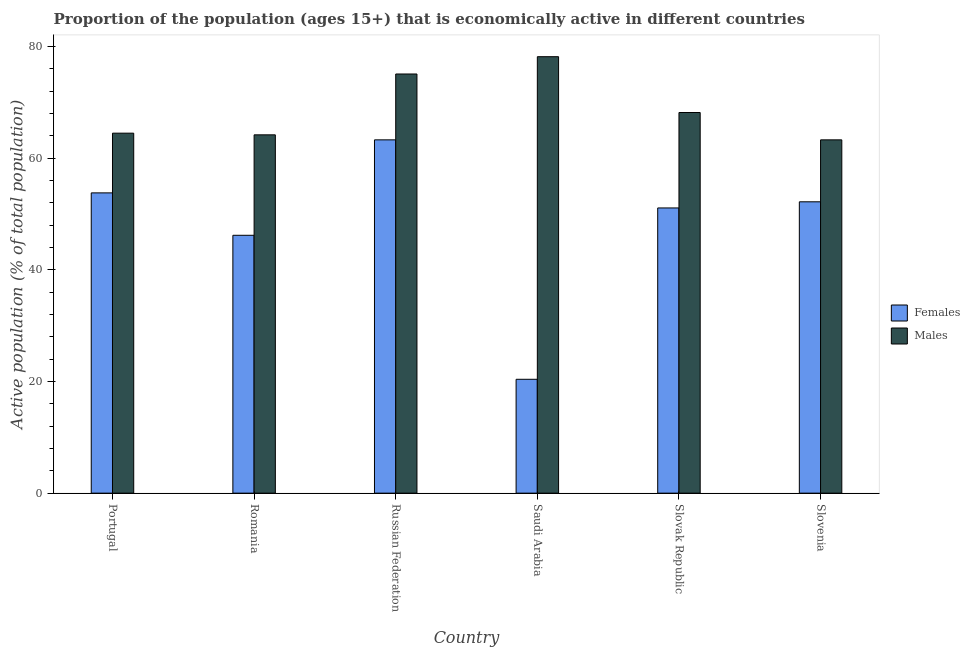How many groups of bars are there?
Give a very brief answer. 6. What is the label of the 3rd group of bars from the left?
Your answer should be compact. Russian Federation. In how many cases, is the number of bars for a given country not equal to the number of legend labels?
Your answer should be very brief. 0. What is the percentage of economically active female population in Slovak Republic?
Ensure brevity in your answer.  51.1. Across all countries, what is the maximum percentage of economically active male population?
Your response must be concise. 78.2. Across all countries, what is the minimum percentage of economically active female population?
Ensure brevity in your answer.  20.4. In which country was the percentage of economically active female population maximum?
Make the answer very short. Russian Federation. In which country was the percentage of economically active male population minimum?
Make the answer very short. Slovenia. What is the total percentage of economically active male population in the graph?
Offer a terse response. 413.5. What is the difference between the percentage of economically active female population in Romania and that in Russian Federation?
Provide a succinct answer. -17.1. What is the difference between the percentage of economically active female population in Slovenia and the percentage of economically active male population in Saudi Arabia?
Your answer should be compact. -26. What is the average percentage of economically active female population per country?
Your response must be concise. 47.83. What is the difference between the percentage of economically active female population and percentage of economically active male population in Portugal?
Provide a short and direct response. -10.7. In how many countries, is the percentage of economically active male population greater than 64 %?
Your response must be concise. 5. What is the ratio of the percentage of economically active male population in Russian Federation to that in Slovenia?
Your answer should be compact. 1.19. Is the percentage of economically active male population in Portugal less than that in Russian Federation?
Give a very brief answer. Yes. What is the difference between the highest and the second highest percentage of economically active male population?
Offer a very short reply. 3.1. What is the difference between the highest and the lowest percentage of economically active female population?
Make the answer very short. 42.9. In how many countries, is the percentage of economically active male population greater than the average percentage of economically active male population taken over all countries?
Offer a terse response. 2. What does the 2nd bar from the left in Romania represents?
Ensure brevity in your answer.  Males. What does the 1st bar from the right in Slovenia represents?
Provide a succinct answer. Males. Are all the bars in the graph horizontal?
Make the answer very short. No. How many countries are there in the graph?
Your response must be concise. 6. What is the difference between two consecutive major ticks on the Y-axis?
Your answer should be compact. 20. Are the values on the major ticks of Y-axis written in scientific E-notation?
Give a very brief answer. No. Does the graph contain any zero values?
Make the answer very short. No. Does the graph contain grids?
Keep it short and to the point. No. Where does the legend appear in the graph?
Make the answer very short. Center right. How are the legend labels stacked?
Keep it short and to the point. Vertical. What is the title of the graph?
Offer a very short reply. Proportion of the population (ages 15+) that is economically active in different countries. Does "Female" appear as one of the legend labels in the graph?
Provide a succinct answer. No. What is the label or title of the X-axis?
Provide a short and direct response. Country. What is the label or title of the Y-axis?
Offer a very short reply. Active population (% of total population). What is the Active population (% of total population) in Females in Portugal?
Your answer should be compact. 53.8. What is the Active population (% of total population) in Males in Portugal?
Provide a succinct answer. 64.5. What is the Active population (% of total population) in Females in Romania?
Offer a terse response. 46.2. What is the Active population (% of total population) in Males in Romania?
Provide a short and direct response. 64.2. What is the Active population (% of total population) in Females in Russian Federation?
Your response must be concise. 63.3. What is the Active population (% of total population) of Males in Russian Federation?
Keep it short and to the point. 75.1. What is the Active population (% of total population) of Females in Saudi Arabia?
Make the answer very short. 20.4. What is the Active population (% of total population) in Males in Saudi Arabia?
Provide a short and direct response. 78.2. What is the Active population (% of total population) in Females in Slovak Republic?
Keep it short and to the point. 51.1. What is the Active population (% of total population) in Males in Slovak Republic?
Your answer should be compact. 68.2. What is the Active population (% of total population) in Females in Slovenia?
Ensure brevity in your answer.  52.2. What is the Active population (% of total population) in Males in Slovenia?
Give a very brief answer. 63.3. Across all countries, what is the maximum Active population (% of total population) in Females?
Provide a succinct answer. 63.3. Across all countries, what is the maximum Active population (% of total population) of Males?
Your response must be concise. 78.2. Across all countries, what is the minimum Active population (% of total population) of Females?
Ensure brevity in your answer.  20.4. Across all countries, what is the minimum Active population (% of total population) of Males?
Give a very brief answer. 63.3. What is the total Active population (% of total population) in Females in the graph?
Keep it short and to the point. 287. What is the total Active population (% of total population) of Males in the graph?
Ensure brevity in your answer.  413.5. What is the difference between the Active population (% of total population) in Females in Portugal and that in Romania?
Provide a succinct answer. 7.6. What is the difference between the Active population (% of total population) of Males in Portugal and that in Russian Federation?
Your answer should be very brief. -10.6. What is the difference between the Active population (% of total population) of Females in Portugal and that in Saudi Arabia?
Make the answer very short. 33.4. What is the difference between the Active population (% of total population) of Males in Portugal and that in Saudi Arabia?
Provide a short and direct response. -13.7. What is the difference between the Active population (% of total population) of Females in Portugal and that in Slovenia?
Your answer should be compact. 1.6. What is the difference between the Active population (% of total population) of Males in Portugal and that in Slovenia?
Your response must be concise. 1.2. What is the difference between the Active population (% of total population) of Females in Romania and that in Russian Federation?
Provide a short and direct response. -17.1. What is the difference between the Active population (% of total population) of Females in Romania and that in Saudi Arabia?
Make the answer very short. 25.8. What is the difference between the Active population (% of total population) in Females in Romania and that in Slovak Republic?
Offer a terse response. -4.9. What is the difference between the Active population (% of total population) in Males in Romania and that in Slovak Republic?
Make the answer very short. -4. What is the difference between the Active population (% of total population) of Males in Romania and that in Slovenia?
Give a very brief answer. 0.9. What is the difference between the Active population (% of total population) in Females in Russian Federation and that in Saudi Arabia?
Give a very brief answer. 42.9. What is the difference between the Active population (% of total population) in Males in Russian Federation and that in Saudi Arabia?
Your answer should be very brief. -3.1. What is the difference between the Active population (% of total population) in Males in Russian Federation and that in Slovak Republic?
Make the answer very short. 6.9. What is the difference between the Active population (% of total population) of Females in Russian Federation and that in Slovenia?
Offer a terse response. 11.1. What is the difference between the Active population (% of total population) of Males in Russian Federation and that in Slovenia?
Your response must be concise. 11.8. What is the difference between the Active population (% of total population) in Females in Saudi Arabia and that in Slovak Republic?
Your answer should be compact. -30.7. What is the difference between the Active population (% of total population) in Males in Saudi Arabia and that in Slovak Republic?
Give a very brief answer. 10. What is the difference between the Active population (% of total population) in Females in Saudi Arabia and that in Slovenia?
Your answer should be compact. -31.8. What is the difference between the Active population (% of total population) in Males in Slovak Republic and that in Slovenia?
Offer a very short reply. 4.9. What is the difference between the Active population (% of total population) in Females in Portugal and the Active population (% of total population) in Males in Russian Federation?
Your answer should be very brief. -21.3. What is the difference between the Active population (% of total population) of Females in Portugal and the Active population (% of total population) of Males in Saudi Arabia?
Your response must be concise. -24.4. What is the difference between the Active population (% of total population) of Females in Portugal and the Active population (% of total population) of Males in Slovak Republic?
Offer a terse response. -14.4. What is the difference between the Active population (% of total population) in Females in Portugal and the Active population (% of total population) in Males in Slovenia?
Your answer should be very brief. -9.5. What is the difference between the Active population (% of total population) of Females in Romania and the Active population (% of total population) of Males in Russian Federation?
Offer a very short reply. -28.9. What is the difference between the Active population (% of total population) of Females in Romania and the Active population (% of total population) of Males in Saudi Arabia?
Your response must be concise. -32. What is the difference between the Active population (% of total population) in Females in Romania and the Active population (% of total population) in Males in Slovenia?
Provide a succinct answer. -17.1. What is the difference between the Active population (% of total population) in Females in Russian Federation and the Active population (% of total population) in Males in Saudi Arabia?
Your response must be concise. -14.9. What is the difference between the Active population (% of total population) in Females in Russian Federation and the Active population (% of total population) in Males in Slovenia?
Make the answer very short. 0. What is the difference between the Active population (% of total population) in Females in Saudi Arabia and the Active population (% of total population) in Males in Slovak Republic?
Make the answer very short. -47.8. What is the difference between the Active population (% of total population) in Females in Saudi Arabia and the Active population (% of total population) in Males in Slovenia?
Ensure brevity in your answer.  -42.9. What is the difference between the Active population (% of total population) in Females in Slovak Republic and the Active population (% of total population) in Males in Slovenia?
Your answer should be compact. -12.2. What is the average Active population (% of total population) of Females per country?
Your answer should be very brief. 47.83. What is the average Active population (% of total population) of Males per country?
Provide a succinct answer. 68.92. What is the difference between the Active population (% of total population) of Females and Active population (% of total population) of Males in Romania?
Give a very brief answer. -18. What is the difference between the Active population (% of total population) of Females and Active population (% of total population) of Males in Saudi Arabia?
Ensure brevity in your answer.  -57.8. What is the difference between the Active population (% of total population) of Females and Active population (% of total population) of Males in Slovak Republic?
Ensure brevity in your answer.  -17.1. What is the difference between the Active population (% of total population) in Females and Active population (% of total population) in Males in Slovenia?
Your answer should be very brief. -11.1. What is the ratio of the Active population (% of total population) of Females in Portugal to that in Romania?
Your response must be concise. 1.16. What is the ratio of the Active population (% of total population) of Females in Portugal to that in Russian Federation?
Keep it short and to the point. 0.85. What is the ratio of the Active population (% of total population) of Males in Portugal to that in Russian Federation?
Provide a succinct answer. 0.86. What is the ratio of the Active population (% of total population) in Females in Portugal to that in Saudi Arabia?
Provide a succinct answer. 2.64. What is the ratio of the Active population (% of total population) of Males in Portugal to that in Saudi Arabia?
Your answer should be compact. 0.82. What is the ratio of the Active population (% of total population) in Females in Portugal to that in Slovak Republic?
Make the answer very short. 1.05. What is the ratio of the Active population (% of total population) in Males in Portugal to that in Slovak Republic?
Give a very brief answer. 0.95. What is the ratio of the Active population (% of total population) of Females in Portugal to that in Slovenia?
Your response must be concise. 1.03. What is the ratio of the Active population (% of total population) of Females in Romania to that in Russian Federation?
Keep it short and to the point. 0.73. What is the ratio of the Active population (% of total population) of Males in Romania to that in Russian Federation?
Offer a terse response. 0.85. What is the ratio of the Active population (% of total population) in Females in Romania to that in Saudi Arabia?
Give a very brief answer. 2.26. What is the ratio of the Active population (% of total population) in Males in Romania to that in Saudi Arabia?
Give a very brief answer. 0.82. What is the ratio of the Active population (% of total population) in Females in Romania to that in Slovak Republic?
Provide a short and direct response. 0.9. What is the ratio of the Active population (% of total population) in Males in Romania to that in Slovak Republic?
Provide a short and direct response. 0.94. What is the ratio of the Active population (% of total population) in Females in Romania to that in Slovenia?
Keep it short and to the point. 0.89. What is the ratio of the Active population (% of total population) in Males in Romania to that in Slovenia?
Keep it short and to the point. 1.01. What is the ratio of the Active population (% of total population) in Females in Russian Federation to that in Saudi Arabia?
Your response must be concise. 3.1. What is the ratio of the Active population (% of total population) of Males in Russian Federation to that in Saudi Arabia?
Your answer should be compact. 0.96. What is the ratio of the Active population (% of total population) of Females in Russian Federation to that in Slovak Republic?
Give a very brief answer. 1.24. What is the ratio of the Active population (% of total population) in Males in Russian Federation to that in Slovak Republic?
Provide a succinct answer. 1.1. What is the ratio of the Active population (% of total population) in Females in Russian Federation to that in Slovenia?
Your answer should be very brief. 1.21. What is the ratio of the Active population (% of total population) of Males in Russian Federation to that in Slovenia?
Offer a terse response. 1.19. What is the ratio of the Active population (% of total population) of Females in Saudi Arabia to that in Slovak Republic?
Provide a short and direct response. 0.4. What is the ratio of the Active population (% of total population) of Males in Saudi Arabia to that in Slovak Republic?
Ensure brevity in your answer.  1.15. What is the ratio of the Active population (% of total population) of Females in Saudi Arabia to that in Slovenia?
Your answer should be very brief. 0.39. What is the ratio of the Active population (% of total population) of Males in Saudi Arabia to that in Slovenia?
Keep it short and to the point. 1.24. What is the ratio of the Active population (% of total population) of Females in Slovak Republic to that in Slovenia?
Your answer should be compact. 0.98. What is the ratio of the Active population (% of total population) of Males in Slovak Republic to that in Slovenia?
Make the answer very short. 1.08. What is the difference between the highest and the second highest Active population (% of total population) in Males?
Provide a short and direct response. 3.1. What is the difference between the highest and the lowest Active population (% of total population) in Females?
Keep it short and to the point. 42.9. What is the difference between the highest and the lowest Active population (% of total population) in Males?
Provide a succinct answer. 14.9. 